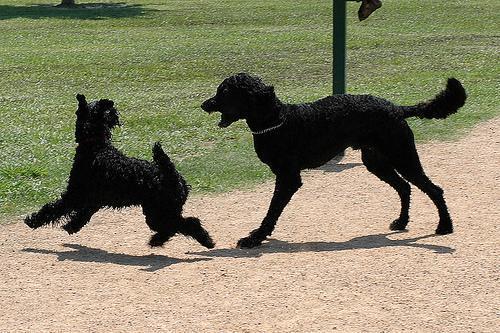How many dogs are wearing a chain collar?
Give a very brief answer. 1. 